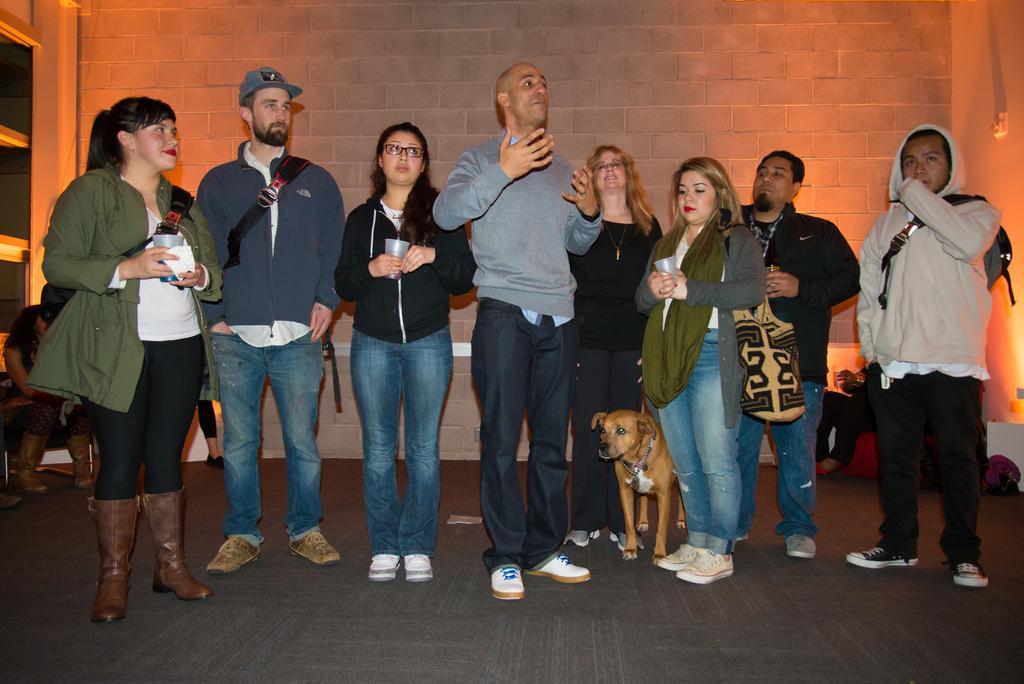In one or two sentences, can you explain what this image depicts? In the center of this picture we can see the group of persons standing on the ground and there is a dog standing on the ground. In the background there are some persons seems to be sitting on the chairs. In the background we can see the wall and the door. 